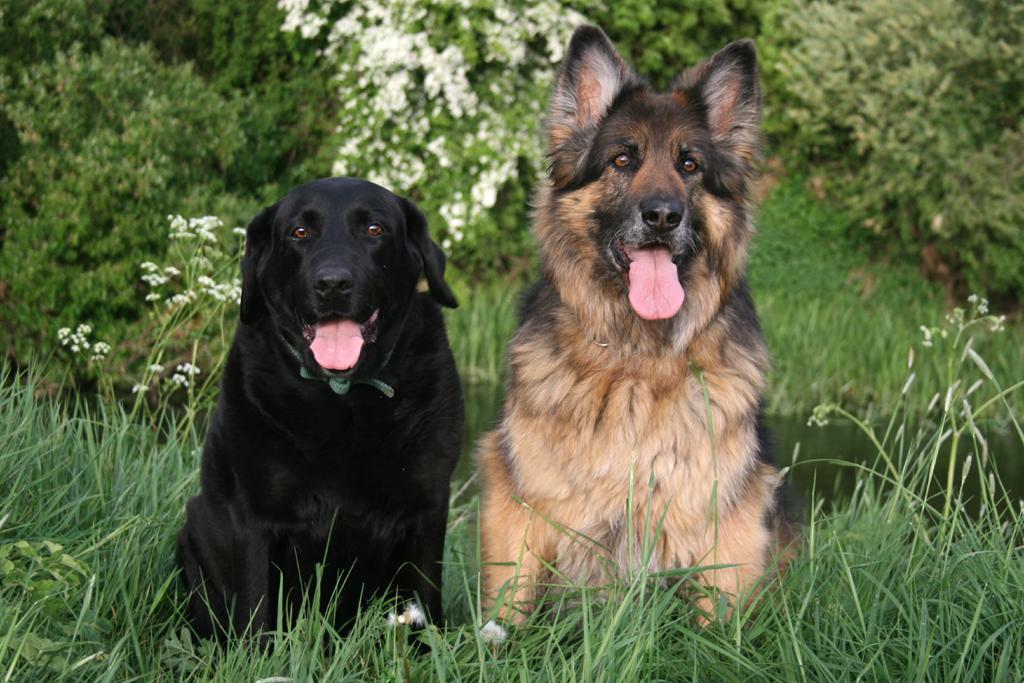In one or two sentences, can you explain what this image depicts? In this image two dogs are sitting on the grass. Behind them there is water. Top of image there are few plants having flowers. There are few trees on the grassland. 